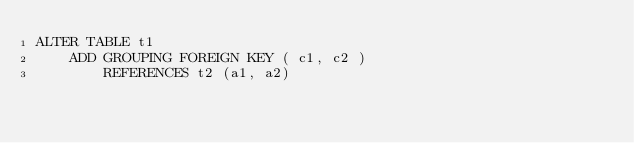Convert code to text. <code><loc_0><loc_0><loc_500><loc_500><_SQL_>ALTER TABLE t1
    ADD GROUPING FOREIGN KEY ( c1, c2 )
        REFERENCES t2 (a1, a2)</code> 